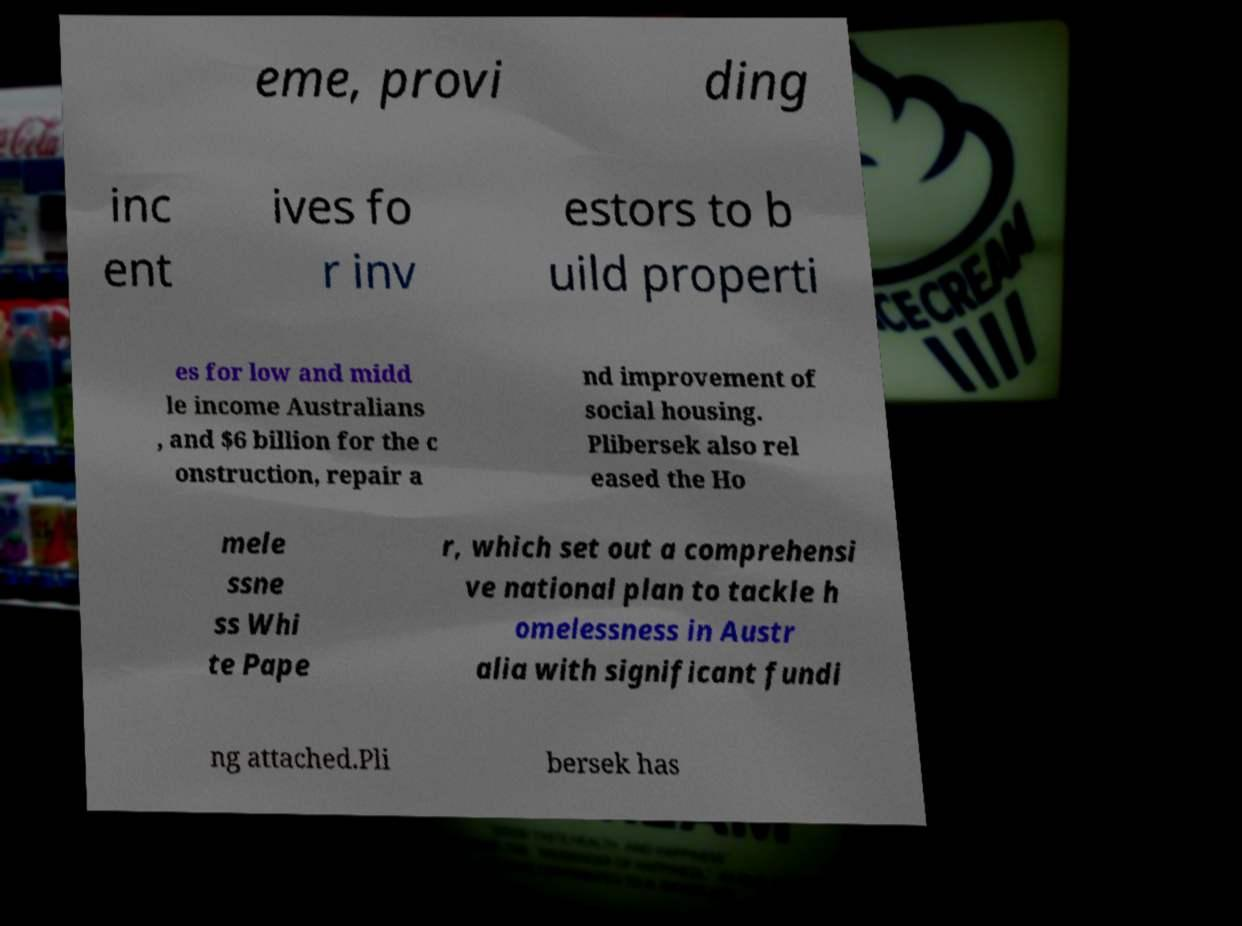Can you read and provide the text displayed in the image?This photo seems to have some interesting text. Can you extract and type it out for me? eme, provi ding inc ent ives fo r inv estors to b uild properti es for low and midd le income Australians , and $6 billion for the c onstruction, repair a nd improvement of social housing. Plibersek also rel eased the Ho mele ssne ss Whi te Pape r, which set out a comprehensi ve national plan to tackle h omelessness in Austr alia with significant fundi ng attached.Pli bersek has 